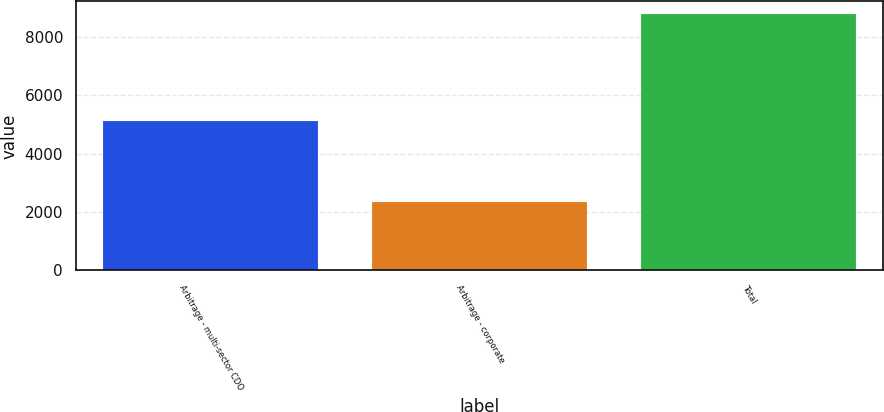Convert chart. <chart><loc_0><loc_0><loc_500><loc_500><bar_chart><fcel>Arbitrage - multi-sector CDO<fcel>Arbitrage - corporate<fcel>Total<nl><fcel>5129<fcel>2349<fcel>8765<nl></chart> 